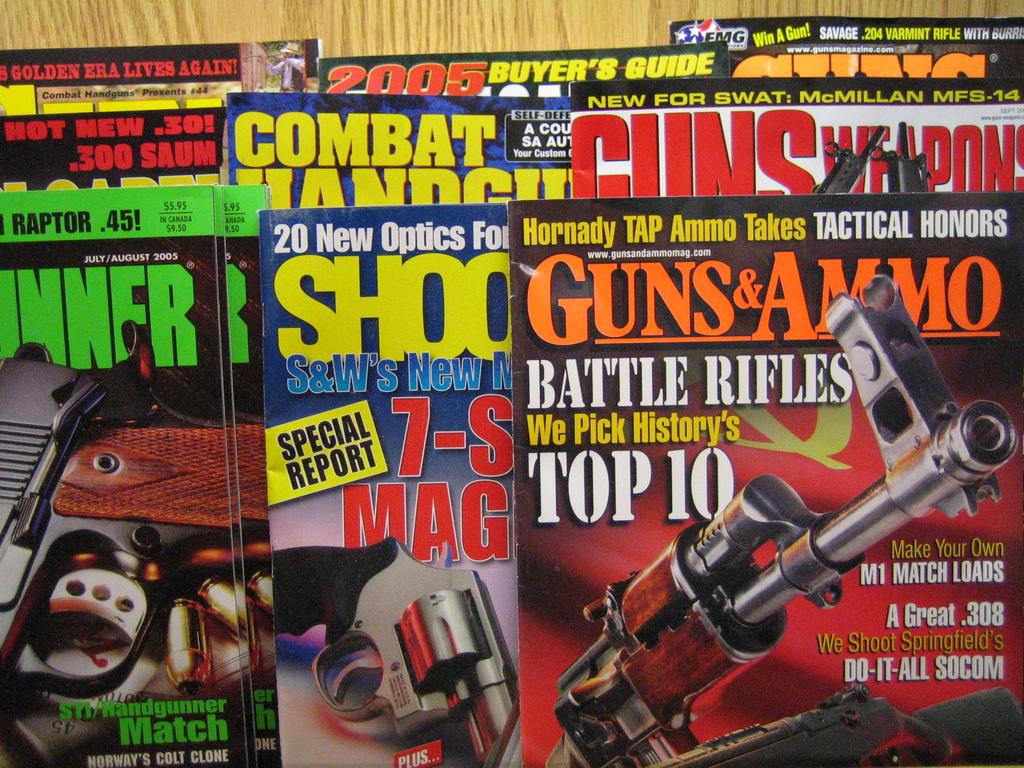What brand of magazines are there?
Make the answer very short. Guns & ammo. Is this magazine for riffles?
Offer a very short reply. Yes. 